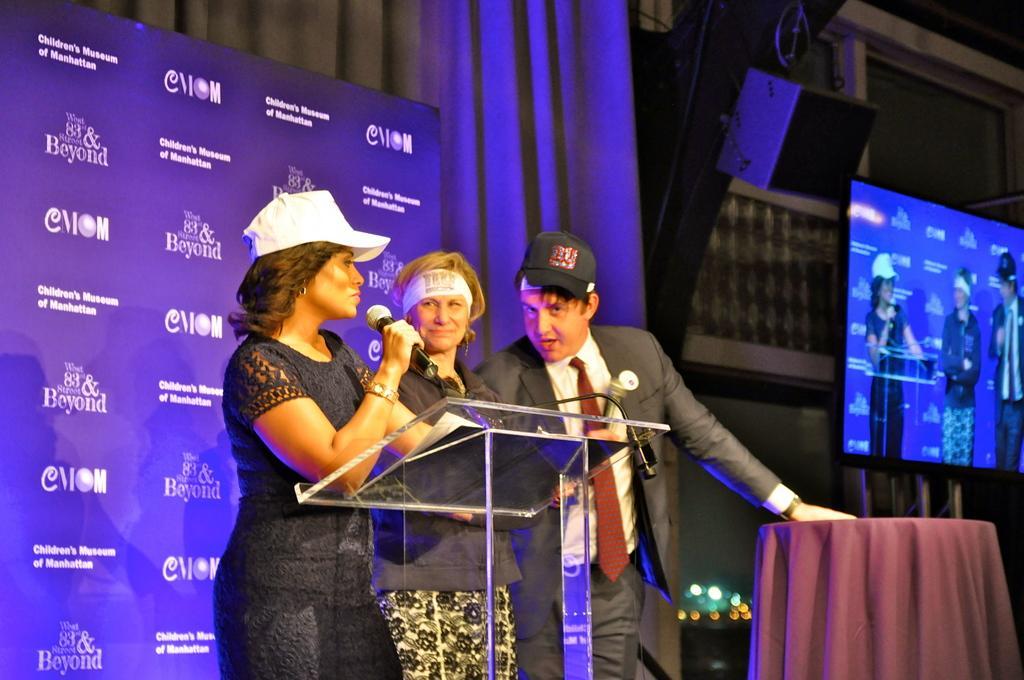Describe this image in one or two sentences. In the picture I can see two women and a man standing on the floor. The woman on the left side and the man on the right side are holding microphones in hands and wearing hats. In the background I can see a banner, curtains, a TV and some other objects. I can also see a podium. 